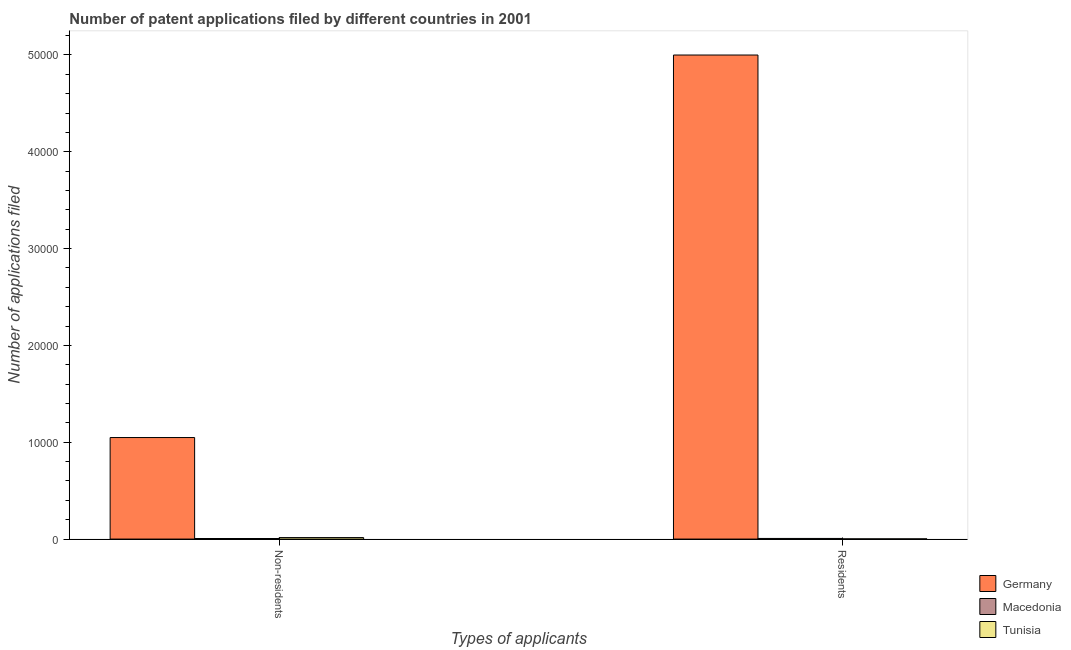Are the number of bars per tick equal to the number of legend labels?
Your answer should be very brief. Yes. Are the number of bars on each tick of the X-axis equal?
Ensure brevity in your answer.  Yes. What is the label of the 1st group of bars from the left?
Offer a very short reply. Non-residents. What is the number of patent applications by non residents in Macedonia?
Keep it short and to the point. 59. Across all countries, what is the maximum number of patent applications by residents?
Make the answer very short. 5.00e+04. Across all countries, what is the minimum number of patent applications by non residents?
Ensure brevity in your answer.  59. In which country was the number of patent applications by non residents maximum?
Ensure brevity in your answer.  Germany. In which country was the number of patent applications by non residents minimum?
Give a very brief answer. Macedonia. What is the total number of patent applications by residents in the graph?
Provide a short and direct response. 5.01e+04. What is the difference between the number of patent applications by non residents in Macedonia and that in Germany?
Your response must be concise. -1.04e+04. What is the difference between the number of patent applications by residents in Tunisia and the number of patent applications by non residents in Germany?
Your answer should be compact. -1.05e+04. What is the average number of patent applications by residents per country?
Your answer should be compact. 1.67e+04. What is the difference between the number of patent applications by residents and number of patent applications by non residents in Germany?
Offer a very short reply. 3.95e+04. What is the ratio of the number of patent applications by residents in Germany to that in Macedonia?
Provide a succinct answer. 757.41. Is the number of patent applications by residents in Germany less than that in Tunisia?
Your answer should be very brief. No. What does the 2nd bar from the right in Residents represents?
Make the answer very short. Macedonia. How many bars are there?
Keep it short and to the point. 6. How many countries are there in the graph?
Give a very brief answer. 3. What is the difference between two consecutive major ticks on the Y-axis?
Offer a very short reply. 10000. Are the values on the major ticks of Y-axis written in scientific E-notation?
Provide a short and direct response. No. Does the graph contain grids?
Keep it short and to the point. No. What is the title of the graph?
Ensure brevity in your answer.  Number of patent applications filed by different countries in 2001. Does "Serbia" appear as one of the legend labels in the graph?
Give a very brief answer. No. What is the label or title of the X-axis?
Provide a succinct answer. Types of applicants. What is the label or title of the Y-axis?
Offer a very short reply. Number of applications filed. What is the Number of applications filed of Germany in Non-residents?
Make the answer very short. 1.05e+04. What is the Number of applications filed in Macedonia in Non-residents?
Your response must be concise. 59. What is the Number of applications filed in Tunisia in Non-residents?
Give a very brief answer. 156. What is the Number of applications filed of Germany in Residents?
Your answer should be compact. 5.00e+04. What is the Number of applications filed in Tunisia in Residents?
Give a very brief answer. 22. Across all Types of applicants, what is the maximum Number of applications filed in Germany?
Ensure brevity in your answer.  5.00e+04. Across all Types of applicants, what is the maximum Number of applications filed in Tunisia?
Provide a succinct answer. 156. Across all Types of applicants, what is the minimum Number of applications filed of Germany?
Make the answer very short. 1.05e+04. Across all Types of applicants, what is the minimum Number of applications filed of Macedonia?
Make the answer very short. 59. What is the total Number of applications filed in Germany in the graph?
Keep it short and to the point. 6.05e+04. What is the total Number of applications filed of Macedonia in the graph?
Provide a short and direct response. 125. What is the total Number of applications filed in Tunisia in the graph?
Your response must be concise. 178. What is the difference between the Number of applications filed of Germany in Non-residents and that in Residents?
Make the answer very short. -3.95e+04. What is the difference between the Number of applications filed in Macedonia in Non-residents and that in Residents?
Provide a short and direct response. -7. What is the difference between the Number of applications filed in Tunisia in Non-residents and that in Residents?
Keep it short and to the point. 134. What is the difference between the Number of applications filed of Germany in Non-residents and the Number of applications filed of Macedonia in Residents?
Give a very brief answer. 1.04e+04. What is the difference between the Number of applications filed in Germany in Non-residents and the Number of applications filed in Tunisia in Residents?
Provide a succinct answer. 1.05e+04. What is the difference between the Number of applications filed of Macedonia in Non-residents and the Number of applications filed of Tunisia in Residents?
Make the answer very short. 37. What is the average Number of applications filed of Germany per Types of applicants?
Make the answer very short. 3.02e+04. What is the average Number of applications filed in Macedonia per Types of applicants?
Keep it short and to the point. 62.5. What is the average Number of applications filed of Tunisia per Types of applicants?
Make the answer very short. 89. What is the difference between the Number of applications filed of Germany and Number of applications filed of Macedonia in Non-residents?
Provide a succinct answer. 1.04e+04. What is the difference between the Number of applications filed in Germany and Number of applications filed in Tunisia in Non-residents?
Provide a succinct answer. 1.03e+04. What is the difference between the Number of applications filed in Macedonia and Number of applications filed in Tunisia in Non-residents?
Your answer should be compact. -97. What is the difference between the Number of applications filed of Germany and Number of applications filed of Macedonia in Residents?
Offer a terse response. 4.99e+04. What is the difference between the Number of applications filed of Germany and Number of applications filed of Tunisia in Residents?
Keep it short and to the point. 5.00e+04. What is the ratio of the Number of applications filed in Germany in Non-residents to that in Residents?
Provide a short and direct response. 0.21. What is the ratio of the Number of applications filed in Macedonia in Non-residents to that in Residents?
Make the answer very short. 0.89. What is the ratio of the Number of applications filed in Tunisia in Non-residents to that in Residents?
Your answer should be compact. 7.09. What is the difference between the highest and the second highest Number of applications filed of Germany?
Give a very brief answer. 3.95e+04. What is the difference between the highest and the second highest Number of applications filed of Macedonia?
Offer a very short reply. 7. What is the difference between the highest and the second highest Number of applications filed in Tunisia?
Keep it short and to the point. 134. What is the difference between the highest and the lowest Number of applications filed in Germany?
Offer a terse response. 3.95e+04. What is the difference between the highest and the lowest Number of applications filed in Macedonia?
Offer a terse response. 7. What is the difference between the highest and the lowest Number of applications filed in Tunisia?
Keep it short and to the point. 134. 